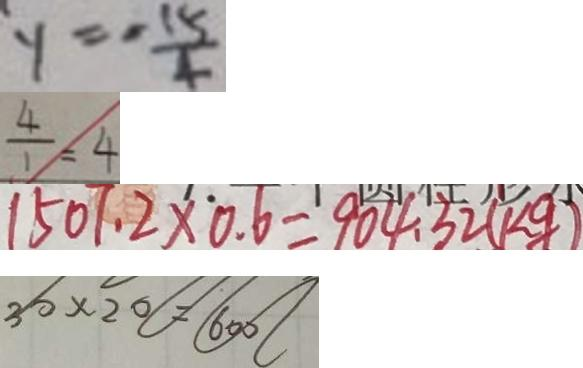<formula> <loc_0><loc_0><loc_500><loc_500>y = - \frac { 1 5 } { 4 } 
 \frac { 4 } { 1 } = 4 
 1 5 0 7 . 2 \times 0 . 6 = 9 0 4 . 3 2 ( k g ) 
 3 0 \times 2 0 = 6 0 0</formula> 